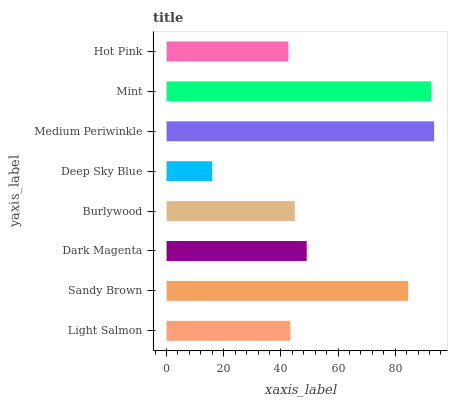Is Deep Sky Blue the minimum?
Answer yes or no. Yes. Is Medium Periwinkle the maximum?
Answer yes or no. Yes. Is Sandy Brown the minimum?
Answer yes or no. No. Is Sandy Brown the maximum?
Answer yes or no. No. Is Sandy Brown greater than Light Salmon?
Answer yes or no. Yes. Is Light Salmon less than Sandy Brown?
Answer yes or no. Yes. Is Light Salmon greater than Sandy Brown?
Answer yes or no. No. Is Sandy Brown less than Light Salmon?
Answer yes or no. No. Is Dark Magenta the high median?
Answer yes or no. Yes. Is Burlywood the low median?
Answer yes or no. Yes. Is Burlywood the high median?
Answer yes or no. No. Is Mint the low median?
Answer yes or no. No. 